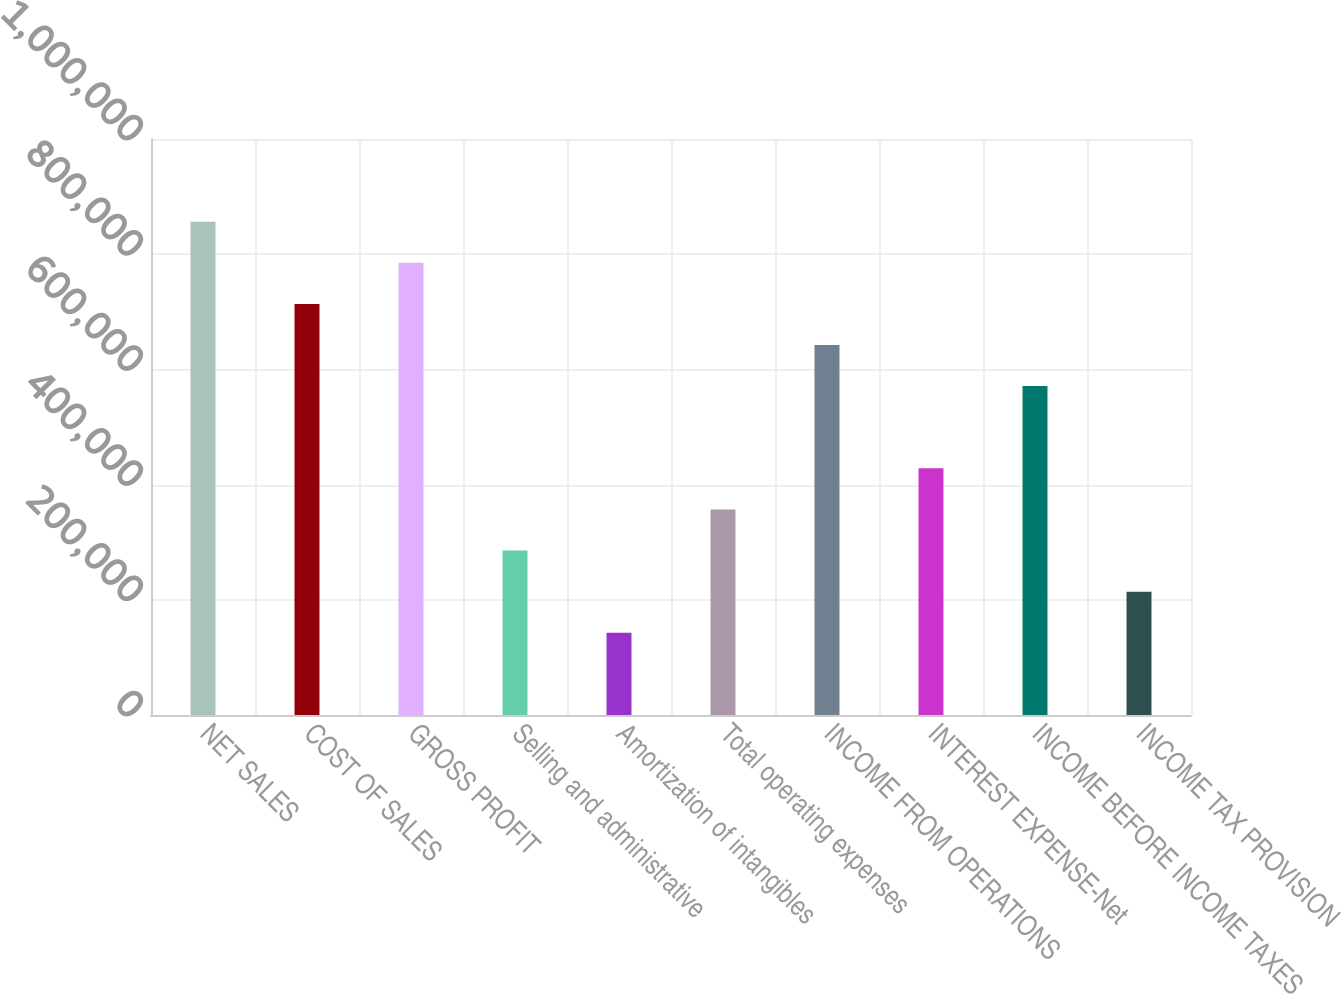Convert chart. <chart><loc_0><loc_0><loc_500><loc_500><bar_chart><fcel>NET SALES<fcel>COST OF SALES<fcel>GROSS PROFIT<fcel>Selling and administrative<fcel>Amortization of intangibles<fcel>Total operating expenses<fcel>INCOME FROM OPERATIONS<fcel>INTEREST EXPENSE-Net<fcel>INCOME BEFORE INCOME TAXES<fcel>INCOME TAX PROVISION<nl><fcel>856453<fcel>713711<fcel>785082<fcel>285486<fcel>142744<fcel>356857<fcel>642340<fcel>428228<fcel>570969<fcel>214115<nl></chart> 